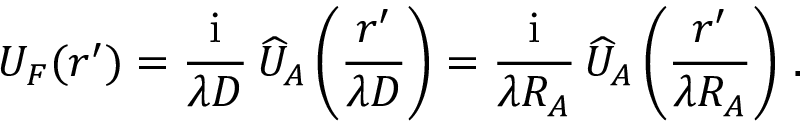Convert formula to latex. <formula><loc_0><loc_0><loc_500><loc_500>U _ { F } ( \boldsymbol r ^ { \prime } ) = { \frac { i } { \lambda D } } \, \widehat { U } _ { A } \left ( { \frac { \boldsymbol r ^ { \prime } } { \lambda D } } \right ) = { \frac { i } { \lambda R _ { A } } } \, \widehat { U } _ { A } \left ( { \frac { \boldsymbol r ^ { \prime } } { \lambda R _ { A } } } \right ) \, .</formula> 